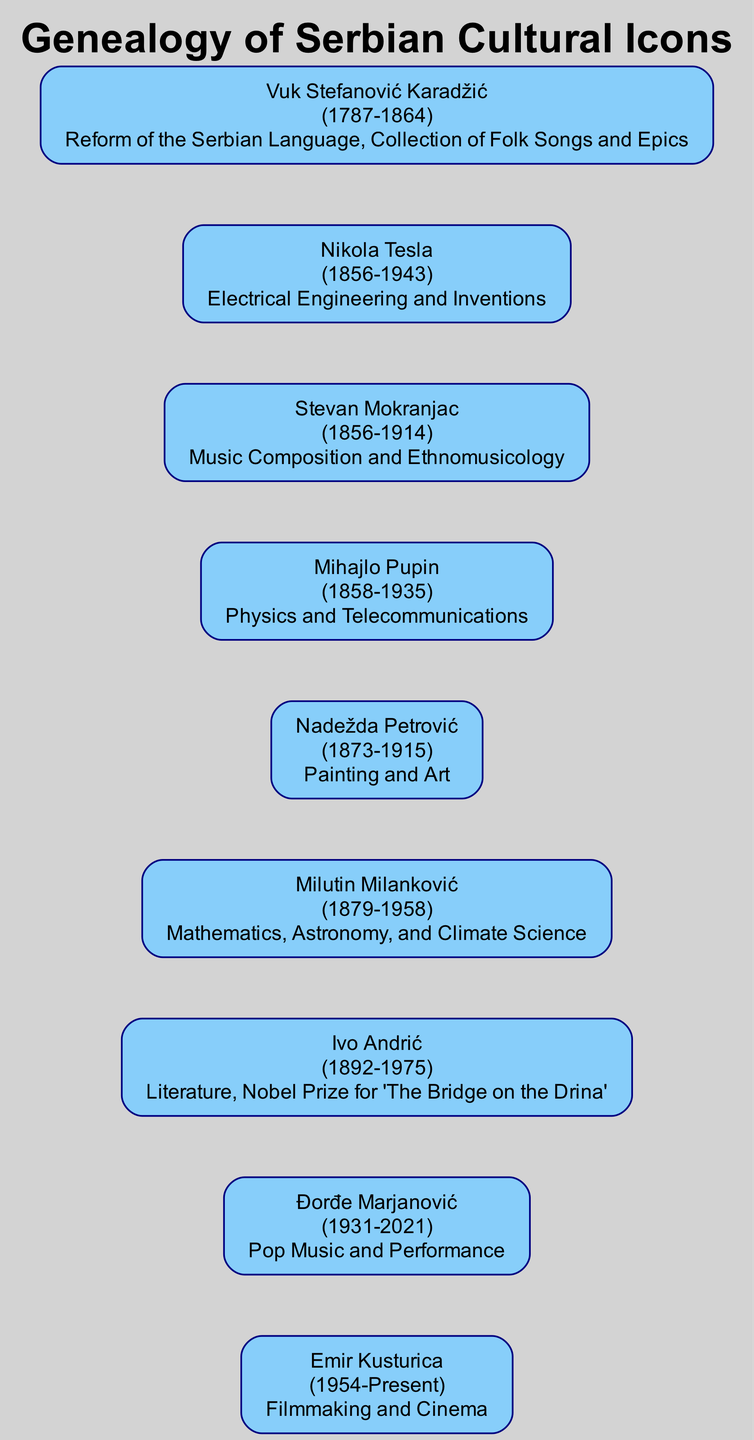What year was Vuk Stefanović Karadžić born? The diagram shows that Vuk Stefanović Karadžić is listed with his birth year, which is prominently displayed next to his name. The year is 1787.
Answer: 1787 Who contributed to Electrical Engineering and Inventions? The diagram clearly states Nikola Tesla as the cultural icon associated with Electrical Engineering and Inventions, as identified in the description next to his name.
Answer: Nikola Tesla How many cultural icons were born in the 19th century? By reviewing the birth years of each cultural icon listed in the diagram, we find that there are six icons: Vuk Stefanović Karadžić, Nikola Tesla, Mihajlo Pupin, Nadežda Petrović, Stevan Mokranjac, and Milutin Milanković, all born in the 19th century.
Answer: 6 Which Serbian cultural icon is associated with the Nobel Prize? The diagram indicates that Ivo Andrić is recognized for receiving the Nobel Prize for his work 'The Bridge on the Drina', connecting him directly to this prestigious award.
Answer: Ivo Andrić What was the contribution of Nadežda Petrović? Nadežda Petrović's contribution is explicitly mentioned in the diagram as "Painting and Art," providing a clear understanding of her impact in the cultural sphere.
Answer: Painting and Art Which two icons were born in the same year? The diagram reveals that both Nikola Tesla and Stevan Mokranjac were born in 1856, showing a shared birth year between these two significant figures.
Answer: 1856 Who is noted for contributions to both Mathematics and Climate Science? By examining the contributions listed, we see that Milutin Milanković is the one recognized for Mathematics, Astronomy, and Climate Science, highlighting his diverse areas of impact.
Answer: Milutin Milanković Which cultural icon lived the longest? The lifespan of each cultural icon can be assessed, and it is clear from the diagram that Đorđe Marjanović, who lived from 1931 to 2021, had the longest life span among the listed icons.
Answer: Đorđe Marjanović Who contributed to Filmmaking and Cinema? According to the diagram, Emir Kusturica is specifically credited with contributions to Filmmaking and Cinema, as his name is associated with that contribution directly beneath it.
Answer: Emir Kusturica 